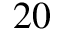<formula> <loc_0><loc_0><loc_500><loc_500>2 0</formula> 